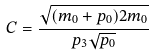<formula> <loc_0><loc_0><loc_500><loc_500>C = \frac { \sqrt { ( m _ { 0 } + p _ { 0 } ) 2 m _ { 0 } } } { p _ { 3 } \sqrt { p _ { 0 } } }</formula> 